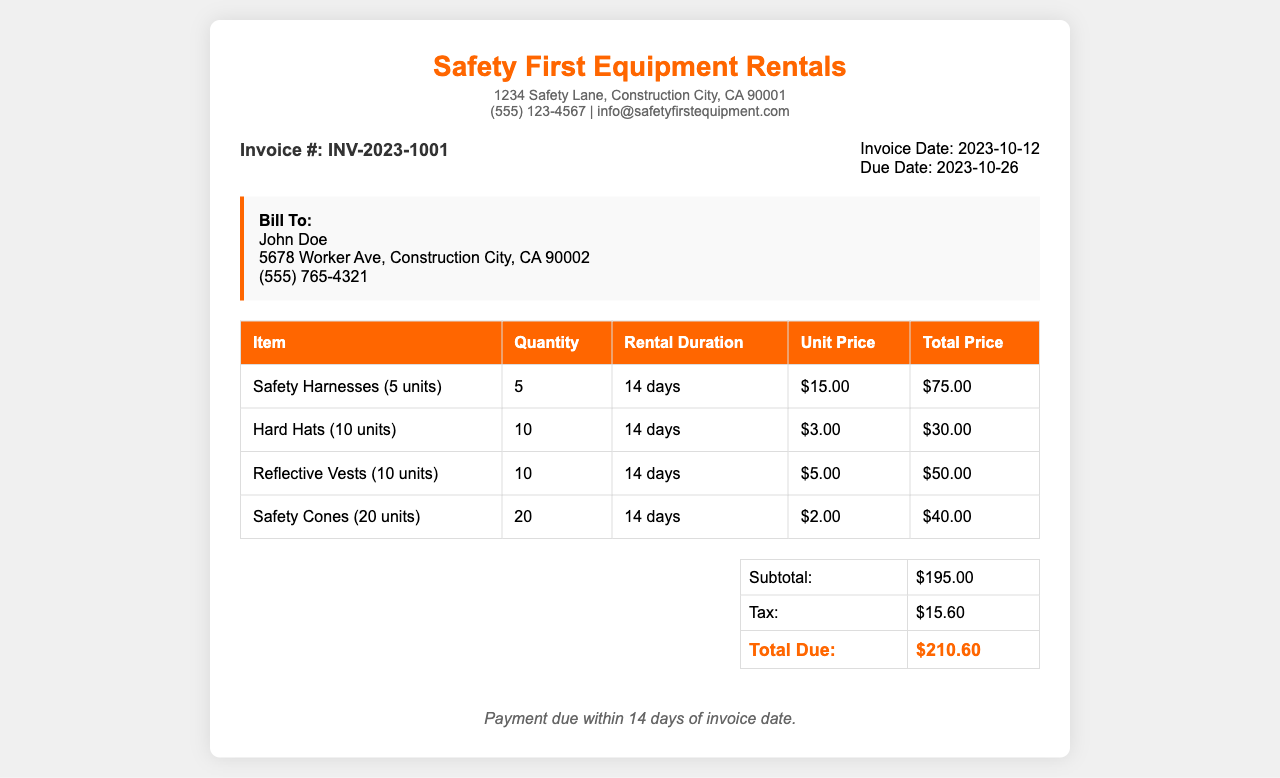What is the invoice number? The invoice number is clearly specified under the invoice details section as INV-2023-1001.
Answer: INV-2023-1001 What is the total due amount? The total due is found at the bottom of the summary table, combining the subtotal and tax, which is $210.60.
Answer: $210.60 How many safety harnesses were rented? The safety harnesses quantity is listed in the itemized table as 5 units.
Answer: 5 What is the rental duration for all items? The rental duration is the same for all items as noted in the table, which is 14 days.
Answer: 14 days What is the tax amount? The tax amount is detailed in the summary table as $15.60.
Answer: $15.60 Who is the client being billed? The client details indicate John Doe as the person being billed.
Answer: John Doe What is the payment term duration? The payment terms section states that payment is due within 14 days of the invoice date.
Answer: 14 days List the item that costs the least per unit. The item with the least cost per unit is the hard hats, with a unit price of $3.00.
Answer: $3.00 What city is the rental company located in? The company's location, as mentioned in the document, is Construction City.
Answer: Construction City 